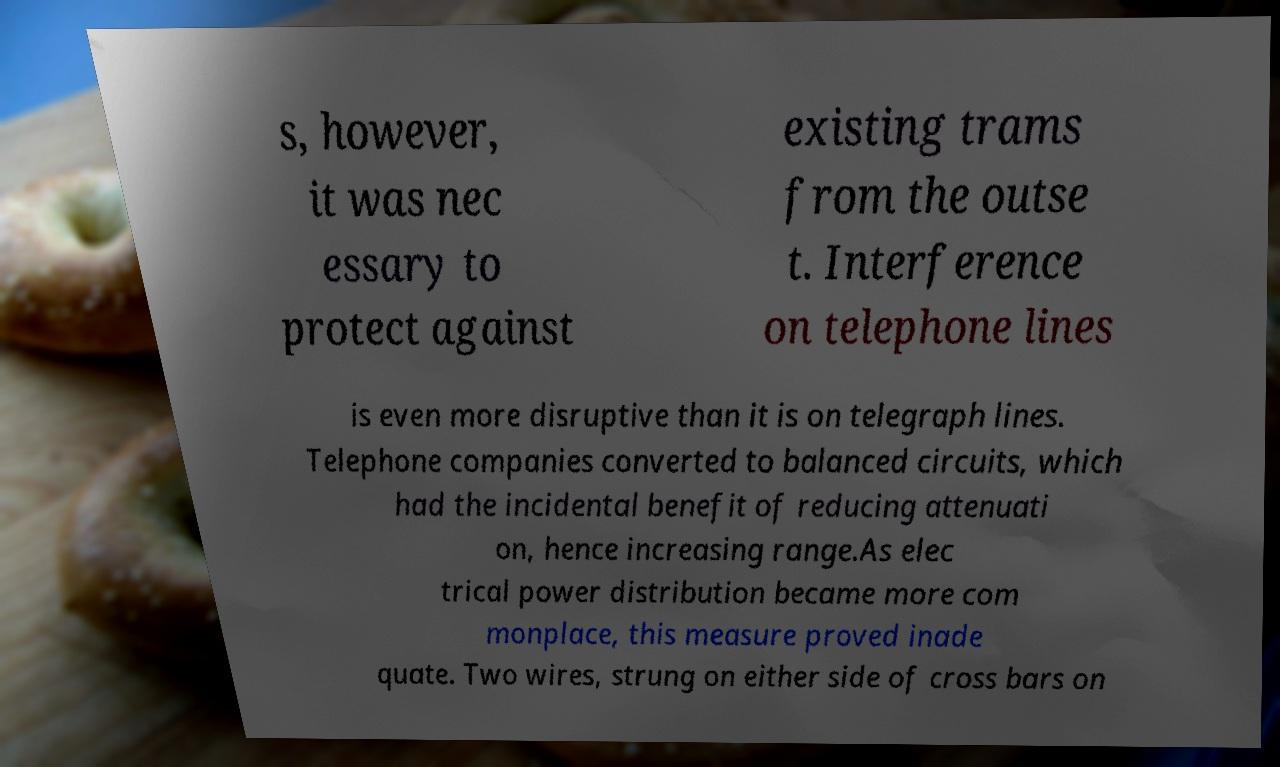Can you accurately transcribe the text from the provided image for me? s, however, it was nec essary to protect against existing trams from the outse t. Interference on telephone lines is even more disruptive than it is on telegraph lines. Telephone companies converted to balanced circuits, which had the incidental benefit of reducing attenuati on, hence increasing range.As elec trical power distribution became more com monplace, this measure proved inade quate. Two wires, strung on either side of cross bars on 